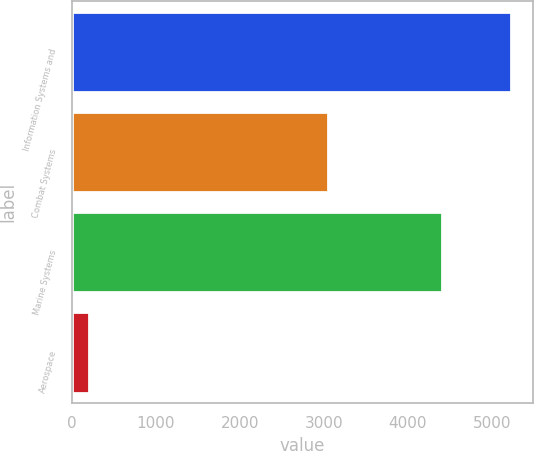Convert chart. <chart><loc_0><loc_0><loc_500><loc_500><bar_chart><fcel>Information Systems and<fcel>Combat Systems<fcel>Marine Systems<fcel>Aerospace<nl><fcel>5229<fcel>3048<fcel>4407<fcel>199<nl></chart> 